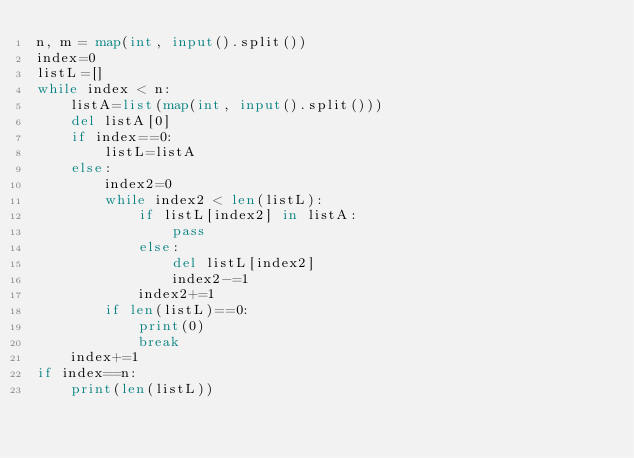Convert code to text. <code><loc_0><loc_0><loc_500><loc_500><_Python_>n, m = map(int, input().split())
index=0
listL=[]
while index < n:
    listA=list(map(int, input().split()))
    del listA[0]
    if index==0:
        listL=listA
    else:
        index2=0
        while index2 < len(listL):
            if listL[index2] in listA:
                pass
            else:
                del listL[index2]
                index2-=1
            index2+=1
        if len(listL)==0:
            print(0)
            break
    index+=1
if index==n:
    print(len(listL))</code> 